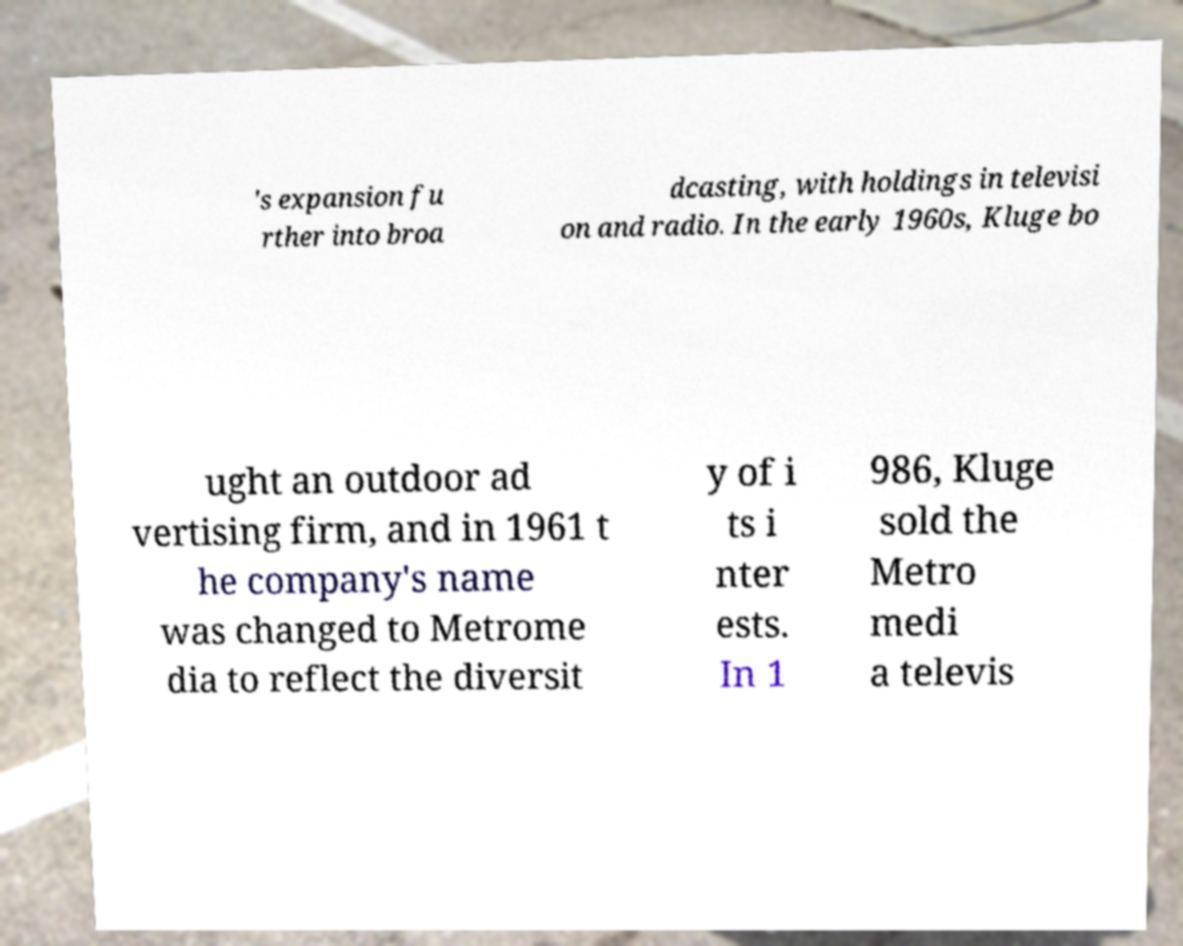Could you extract and type out the text from this image? 's expansion fu rther into broa dcasting, with holdings in televisi on and radio. In the early 1960s, Kluge bo ught an outdoor ad vertising firm, and in 1961 t he company's name was changed to Metrome dia to reflect the diversit y of i ts i nter ests. In 1 986, Kluge sold the Metro medi a televis 